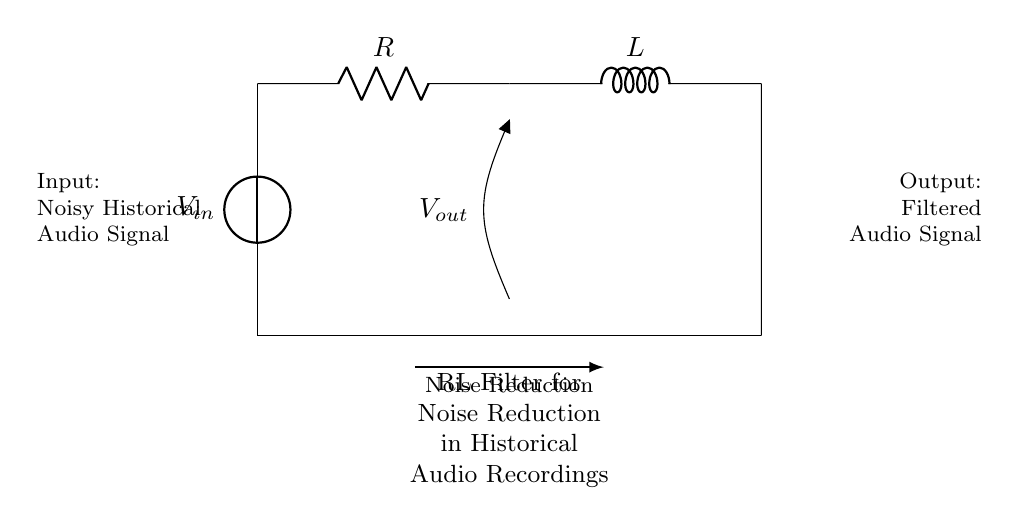What are the components in this circuit? The circuit contains a voltage source, a resistor, and an inductor. These can be identified visually as the different symbols in the diagram.
Answer: Voltage source, resistor, inductor What is the purpose of the circuit? This circuit is an RL filter designed for reducing noise in historical audio recordings. The label on the circuit identifies its main function.
Answer: Noise reduction What type of circuit is depicted? This circuit is a series RL filter circuit, which is characterized by its arrangement of components in a single loop with a resistor and an inductor connected in series.
Answer: Series RL filter What do R and L represent in this circuit? R represents resistance measured in ohms, and L represents inductance measured in henries. Both are basic electrical components with specific functions relevant to filter circuits.
Answer: Resistance and inductance How many nodes are in this circuit? The circuit contains two nodes where components connect: one at the top (between the voltage source and the resistor) and one at the bottom (common ground).
Answer: Two nodes What is the output voltage labeled as? The output voltage is labeled as V_out, indicating it is the voltage taken across the resistor in the filtering circuit.
Answer: V_out How does the RL circuit affect frequencies? The RL circuit allows certain frequencies to pass while attenuating others, particularly reducing high-frequency noise as indicated by its function as a noise reducer.
Answer: Attenuates high frequencies 